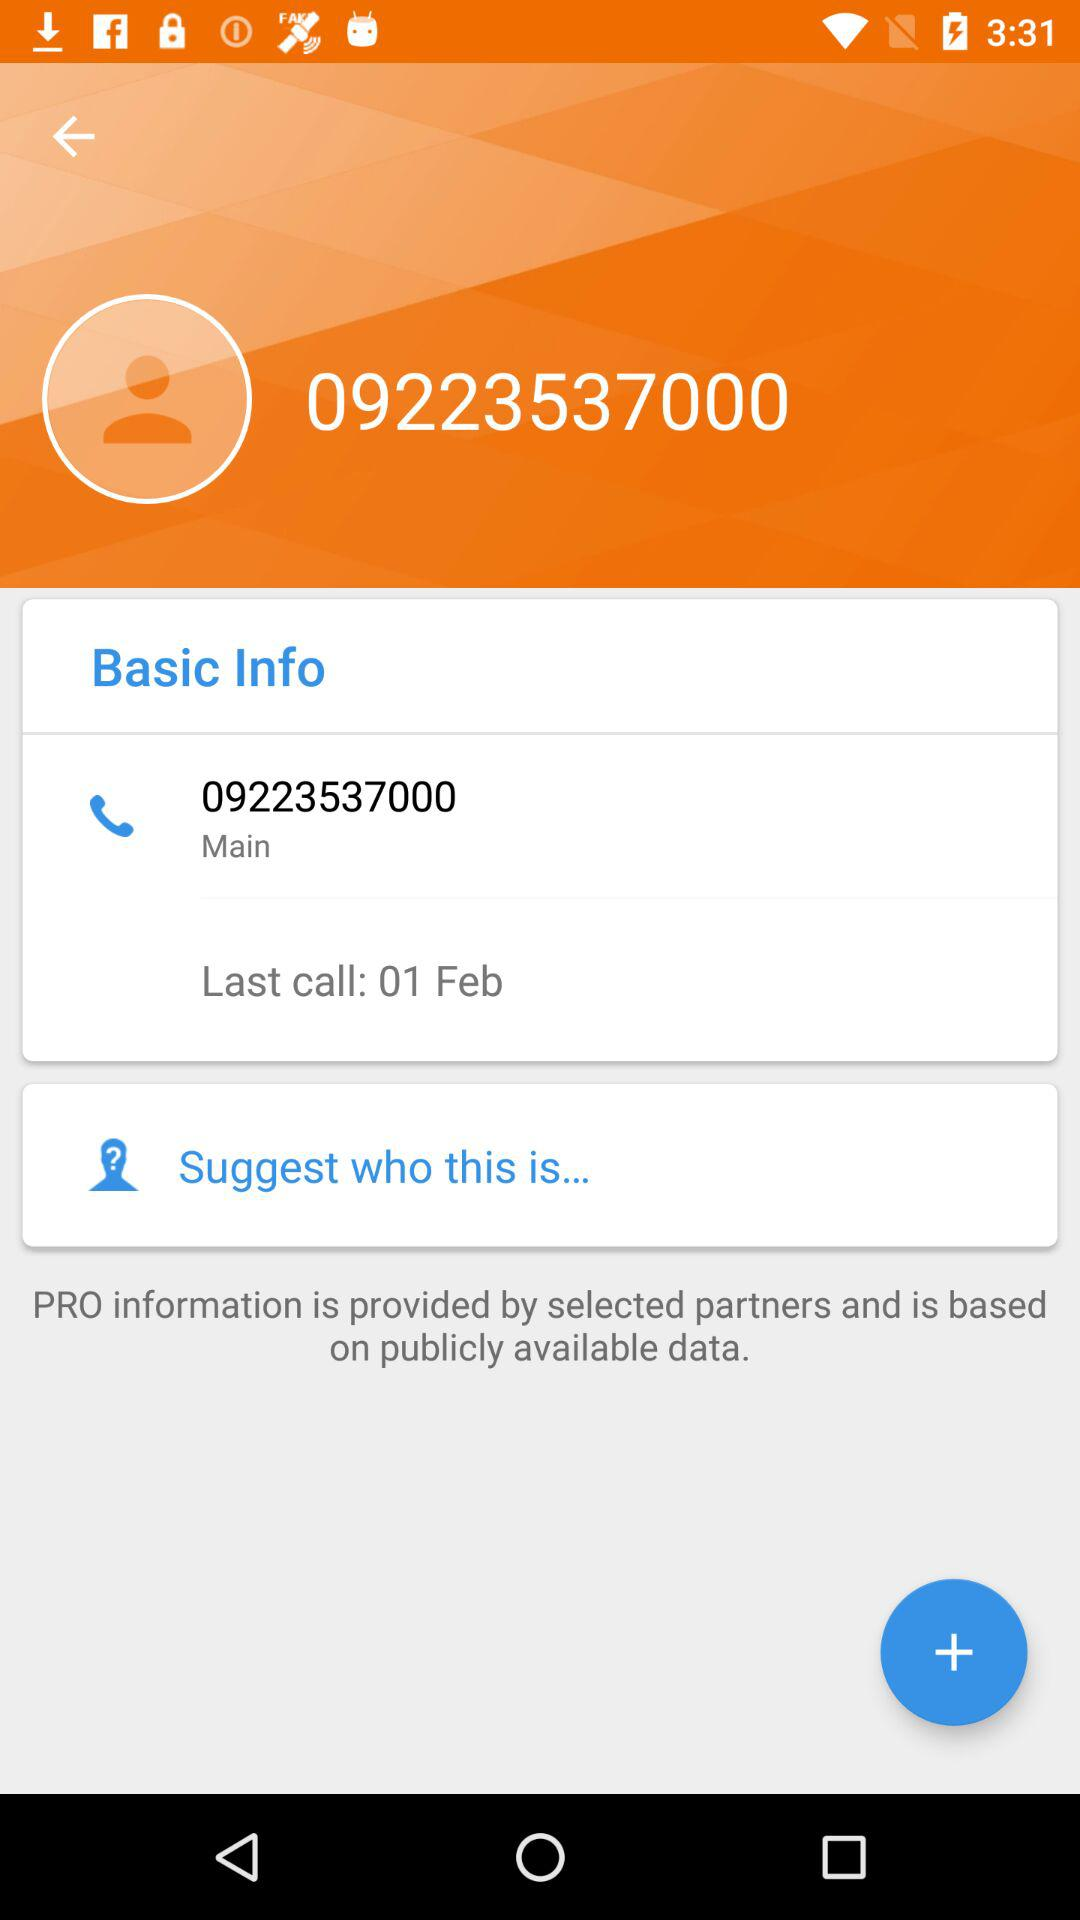What's the date of the last call? The date of the last call is February 1. 